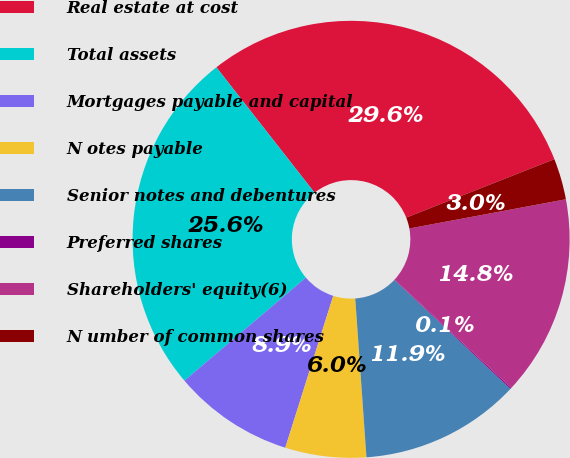<chart> <loc_0><loc_0><loc_500><loc_500><pie_chart><fcel>Real estate at cost<fcel>Total assets<fcel>Mortgages payable and capital<fcel>N otes payable<fcel>Senior notes and debentures<fcel>Preferred shares<fcel>Shareholders' equity(6)<fcel>N umber of common shares<nl><fcel>29.6%<fcel>25.62%<fcel>8.94%<fcel>5.99%<fcel>11.89%<fcel>0.09%<fcel>14.84%<fcel>3.04%<nl></chart> 